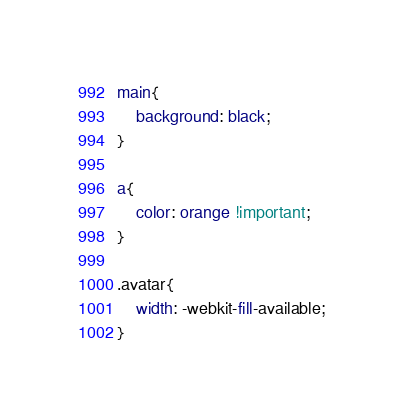<code> <loc_0><loc_0><loc_500><loc_500><_CSS_>

main{
    background: black;
}

a{
    color: orange !important;
}

.avatar{
    width: -webkit-fill-available;
}</code> 